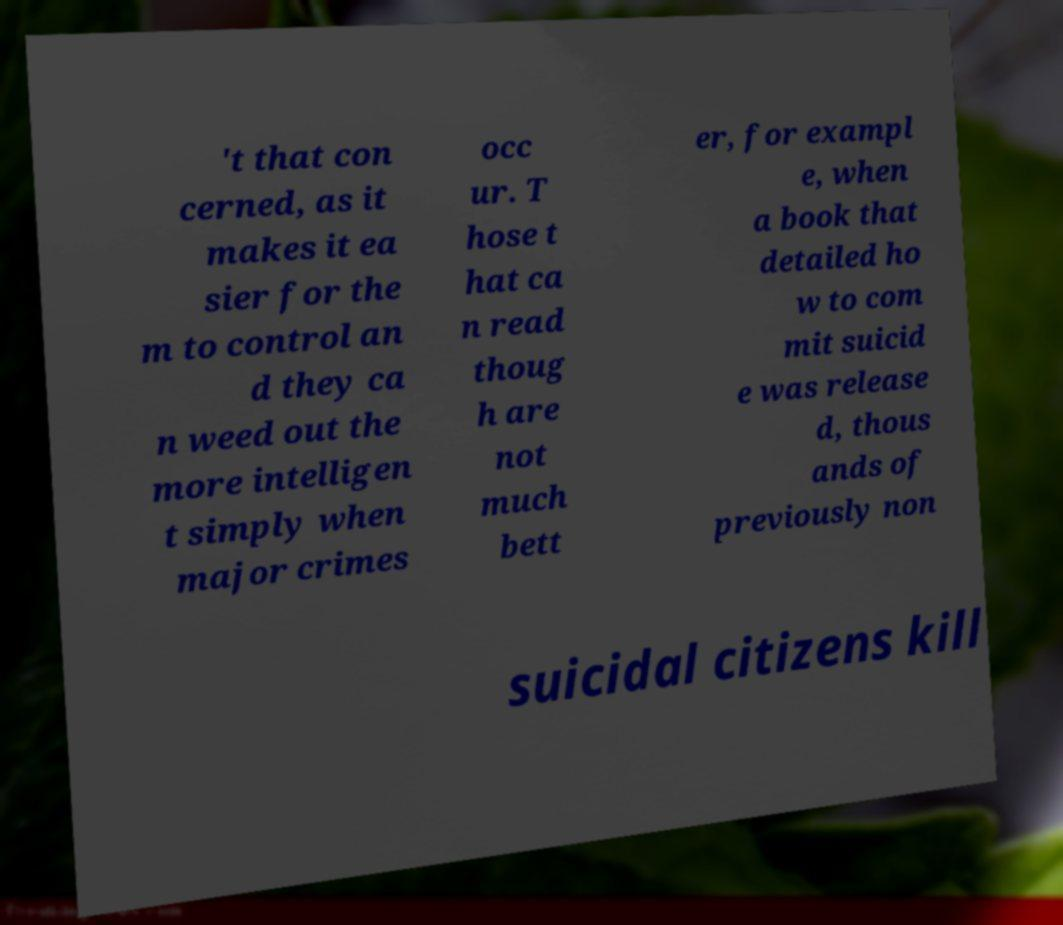Please read and relay the text visible in this image. What does it say? 't that con cerned, as it makes it ea sier for the m to control an d they ca n weed out the more intelligen t simply when major crimes occ ur. T hose t hat ca n read thoug h are not much bett er, for exampl e, when a book that detailed ho w to com mit suicid e was release d, thous ands of previously non suicidal citizens kill 